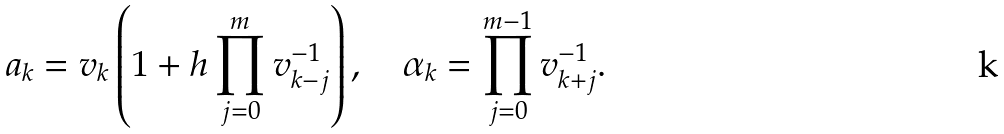<formula> <loc_0><loc_0><loc_500><loc_500>a _ { k } = v _ { k } \left ( 1 + h \prod _ { j = 0 } ^ { m } v _ { k - j } ^ { - 1 } \right ) , \quad \alpha _ { k } = \prod _ { j = 0 } ^ { m - 1 } v _ { k + j } ^ { - 1 } .</formula> 